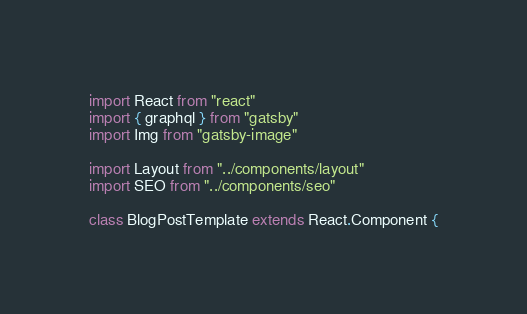<code> <loc_0><loc_0><loc_500><loc_500><_JavaScript_>import React from "react"
import { graphql } from "gatsby"
import Img from "gatsby-image"

import Layout from "../components/layout"
import SEO from "../components/seo"

class BlogPostTemplate extends React.Component {</code> 